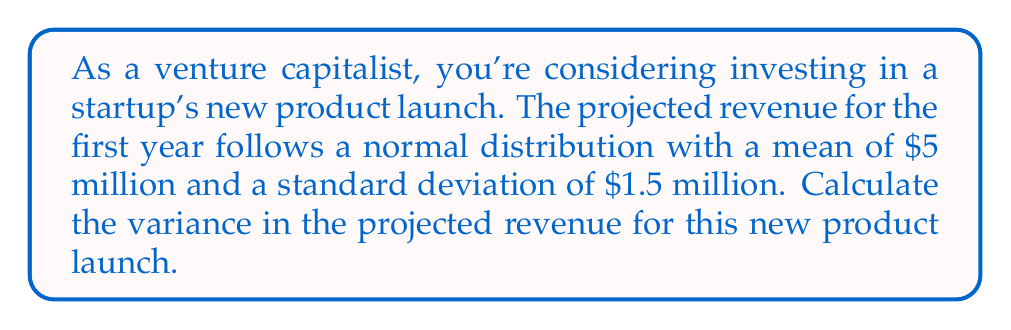Could you help me with this problem? To solve this problem, we need to understand the relationship between standard deviation and variance for a normal distribution.

1. Given information:
   - The projected revenue follows a normal distribution
   - Mean (μ) = $5 million
   - Standard deviation (σ) = $1.5 million

2. Recall the relationship between variance and standard deviation:
   $$ \text{Variance} = \sigma^2 $$

3. Calculate the variance by squaring the standard deviation:
   $$ \text{Variance} = (1.5)^2 = 2.25 $$

4. Interpret the result:
   The variance in projected revenue is $2.25 million squared.

Note: The units of variance are always squared units of the original measurement. In this case, it's (million dollars)².
Answer: The variance in projected revenue for the new product launch is $2.25 million². 